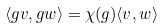Convert formula to latex. <formula><loc_0><loc_0><loc_500><loc_500>\langle g v , g w \rangle = \chi ( g ) \langle v , w \rangle</formula> 